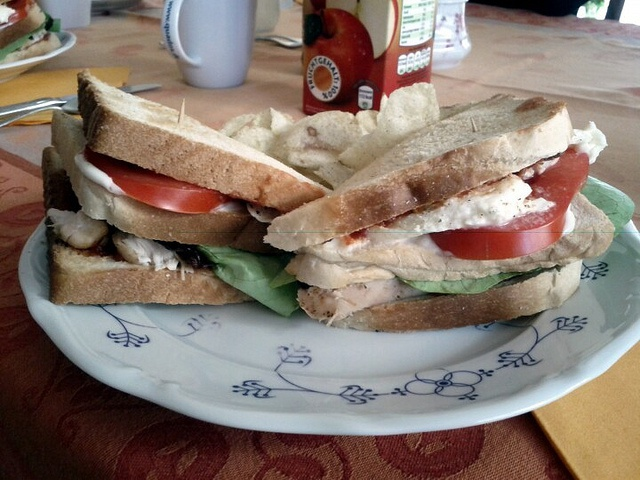Describe the objects in this image and their specific colors. I can see dining table in darkgray, gray, black, and tan tones, sandwich in gray, darkgray, and lightgray tones, sandwich in gray, black, and tan tones, cup in gray and darkgray tones, and spoon in gray, darkgray, and white tones in this image. 